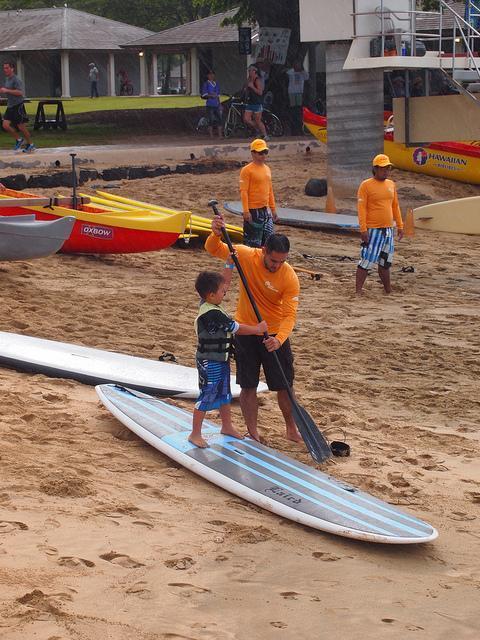How many people are wearing orange shirts?
Give a very brief answer. 3. How many surfboards can be seen?
Give a very brief answer. 3. How many people can you see?
Give a very brief answer. 4. How many boats are there?
Give a very brief answer. 3. How many benches are in the picture?
Give a very brief answer. 0. 